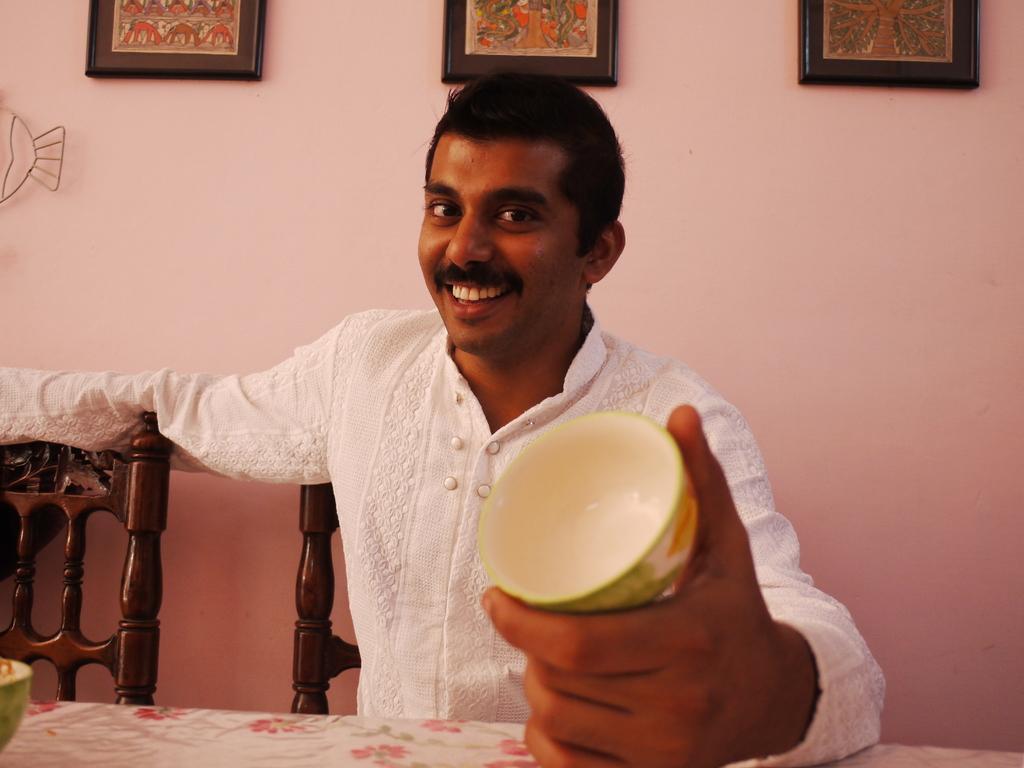Please provide a concise description of this image. In this picture there is a man sitting on the chair and holding a bowl. There are three frames on the wall. There is a white cloth on the table. 